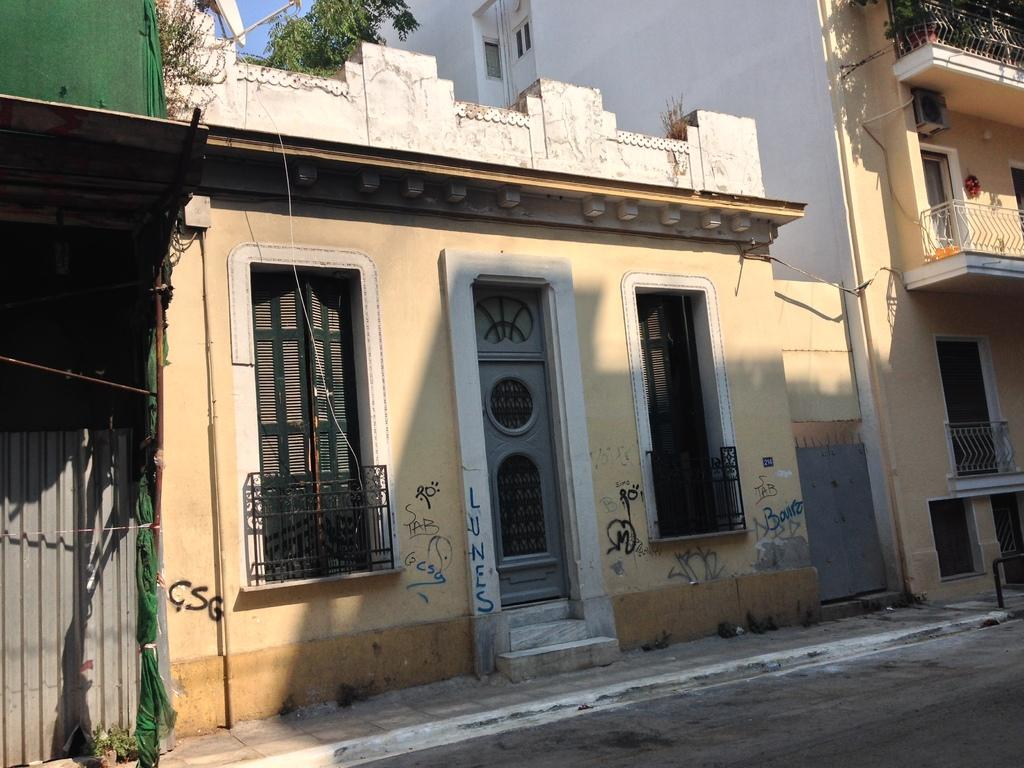What type of structures can be seen in the image? There are houses and buildings in the image. What type of natural elements can be seen in the image? There are trees in the image. What architectural features can be seen in the image? There are windows, doors, and walls in the image. What is the primary mode of transportation visible in the image? There is a road in the image. What part of the natural environment is visible in the image? The sky is visible in the image. What is the tendency of the oranges to grow in the image? There are no oranges present in the image, so it is not possible to determine their tendency to grow. What type of thing is depicted interacting with the buildings in the image? There is no thing depicted interacting with the buildings in the image; only the houses, buildings, trees, windows, doors, walls, road, and sky are present. 